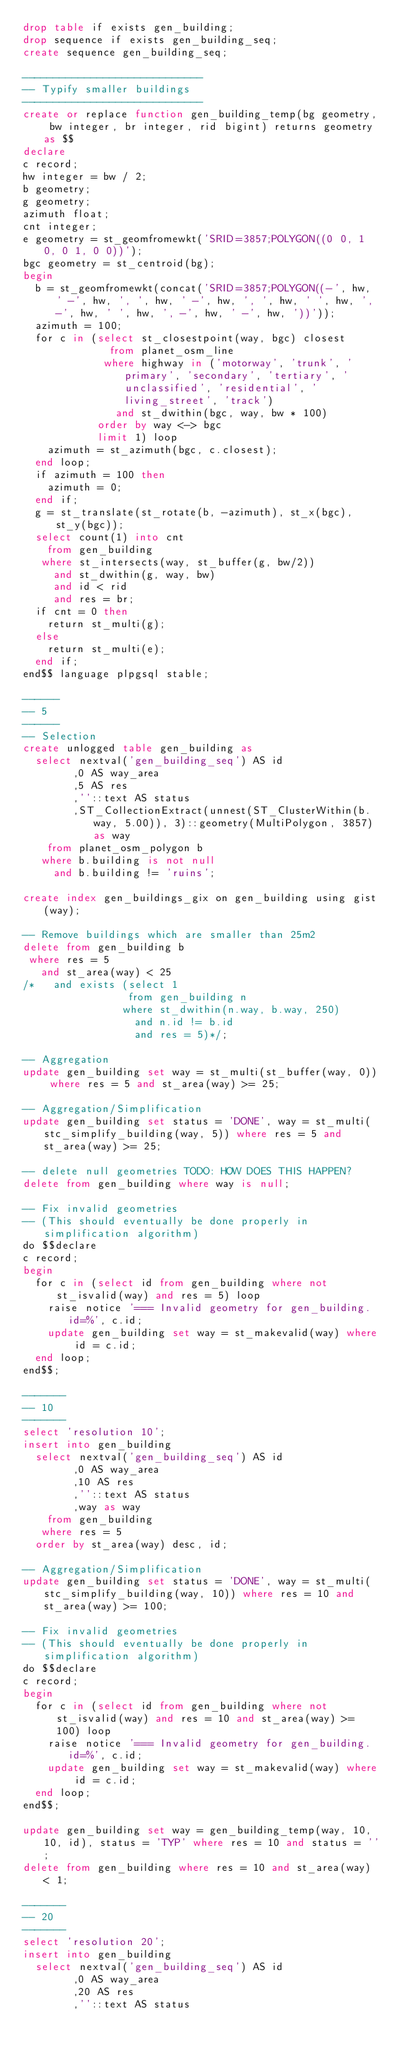<code> <loc_0><loc_0><loc_500><loc_500><_SQL_>drop table if exists gen_building;
drop sequence if exists gen_building_seq;
create sequence gen_building_seq;

-----------------------------
-- Typify smaller buildings
-----------------------------
create or replace function gen_building_temp(bg geometry, bw integer, br integer, rid bigint) returns geometry as $$
declare
c record;
hw integer = bw / 2;
b geometry;
g geometry;
azimuth float;
cnt integer;
e geometry = st_geomfromewkt('SRID=3857;POLYGON((0 0, 1 0, 0 1, 0 0))');
bgc geometry = st_centroid(bg);
begin
  b = st_geomfromewkt(concat('SRID=3857;POLYGON((-', hw, ' -', hw, ', ', hw, ' -', hw, ', ', hw, ' ', hw, ', -', hw, ' ', hw, ', -', hw, ' -', hw, '))'));
  azimuth = 100;
  for c in (select st_closestpoint(way, bgc) closest
              from planet_osm_line
             where highway in ('motorway', 'trunk', 'primary', 'secondary', 'tertiary', 'unclassified', 'residential', 'living_street', 'track')
               and st_dwithin(bgc, way, bw * 100)
            order by way <-> bgc
            limit 1) loop
    azimuth = st_azimuth(bgc, c.closest);
  end loop;
  if azimuth = 100 then
    azimuth = 0;
  end if;
  g = st_translate(st_rotate(b, -azimuth), st_x(bgc), st_y(bgc));
  select count(1) into cnt
    from gen_building
   where st_intersects(way, st_buffer(g, bw/2))
     and st_dwithin(g, way, bw)
     and id < rid
     and res = br;
  if cnt = 0 then
    return st_multi(g);
  else
    return st_multi(e);
  end if;
end$$ language plpgsql stable;

------
-- 5
------
-- Selection
create unlogged table gen_building as
  select nextval('gen_building_seq') AS id
        ,0 AS way_area
        ,5 AS res
        ,''::text AS status
        ,ST_CollectionExtract(unnest(ST_ClusterWithin(b.way, 5.00)), 3)::geometry(MultiPolygon, 3857) as way
    from planet_osm_polygon b
   where b.building is not null
     and b.building != 'ruins';

create index gen_buildings_gix on gen_building using gist(way);

-- Remove buildings which are smaller than 25m2
delete from gen_building b
 where res = 5
   and st_area(way) < 25
/*   and exists (select 1
                 from gen_building n
                where st_dwithin(n.way, b.way, 250)
                  and n.id != b.id
                  and res = 5)*/;

-- Aggregation
update gen_building set way = st_multi(st_buffer(way, 0)) where res = 5 and st_area(way) >= 25;

-- Aggregation/Simplification
update gen_building set status = 'DONE', way = st_multi(stc_simplify_building(way, 5)) where res = 5 and st_area(way) >= 25;

-- delete null geometries TODO: HOW DOES THIS HAPPEN?
delete from gen_building where way is null;

-- Fix invalid geometries
-- (This should eventually be done properly in simplification algorithm)
do $$declare
c record;
begin
  for c in (select id from gen_building where not st_isvalid(way) and res = 5) loop
    raise notice '=== Invalid geometry for gen_building.id=%', c.id;
    update gen_building set way = st_makevalid(way) where id = c.id;
  end loop;
end$$;

-------
-- 10
-------
select 'resolution 10';
insert into gen_building
  select nextval('gen_building_seq') AS id
        ,0 AS way_area
        ,10 AS res
        ,''::text AS status
        ,way as way
    from gen_building
   where res = 5
  order by st_area(way) desc, id;

-- Aggregation/Simplification
update gen_building set status = 'DONE', way = st_multi(stc_simplify_building(way, 10)) where res = 10 and st_area(way) >= 100;

-- Fix invalid geometries
-- (This should eventually be done properly in simplification algorithm)
do $$declare
c record;
begin
  for c in (select id from gen_building where not st_isvalid(way) and res = 10 and st_area(way) >= 100) loop
    raise notice '=== Invalid geometry for gen_building.id=%', c.id;
    update gen_building set way = st_makevalid(way) where id = c.id;
  end loop;
end$$;

update gen_building set way = gen_building_temp(way, 10, 10, id), status = 'TYP' where res = 10 and status = '';
delete from gen_building where res = 10 and st_area(way) < 1;

-------
-- 20
-------
select 'resolution 20';
insert into gen_building
  select nextval('gen_building_seq') AS id
        ,0 AS way_area
        ,20 AS res
        ,''::text AS status</code> 